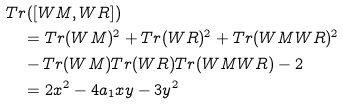<formula> <loc_0><loc_0><loc_500><loc_500>& T r ( [ W M , W R ] ) \\ & \quad = T r ( W M ) ^ { 2 } + T r ( W R ) ^ { 2 } + T r ( W M W R ) ^ { 2 } \\ & \quad - T r ( W M ) T r ( W R ) T r ( W M W R ) - 2 \\ & \quad = 2 x ^ { 2 } - 4 a _ { 1 } x y - 3 y ^ { 2 }</formula> 